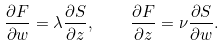<formula> <loc_0><loc_0><loc_500><loc_500>\frac { \partial F } { \partial w } = \lambda \frac { \partial S } { \partial z } , \quad \frac { \partial F } { \partial z } = \nu \frac { \partial S } { \partial w } .</formula> 